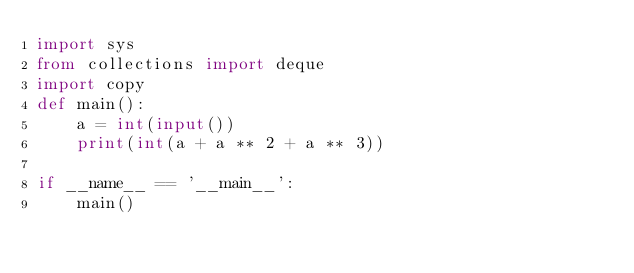<code> <loc_0><loc_0><loc_500><loc_500><_Python_>import sys
from collections import deque
import copy
def main():
    a = int(input())
    print(int(a + a ** 2 + a ** 3))

if __name__ == '__main__':
    main()
</code> 